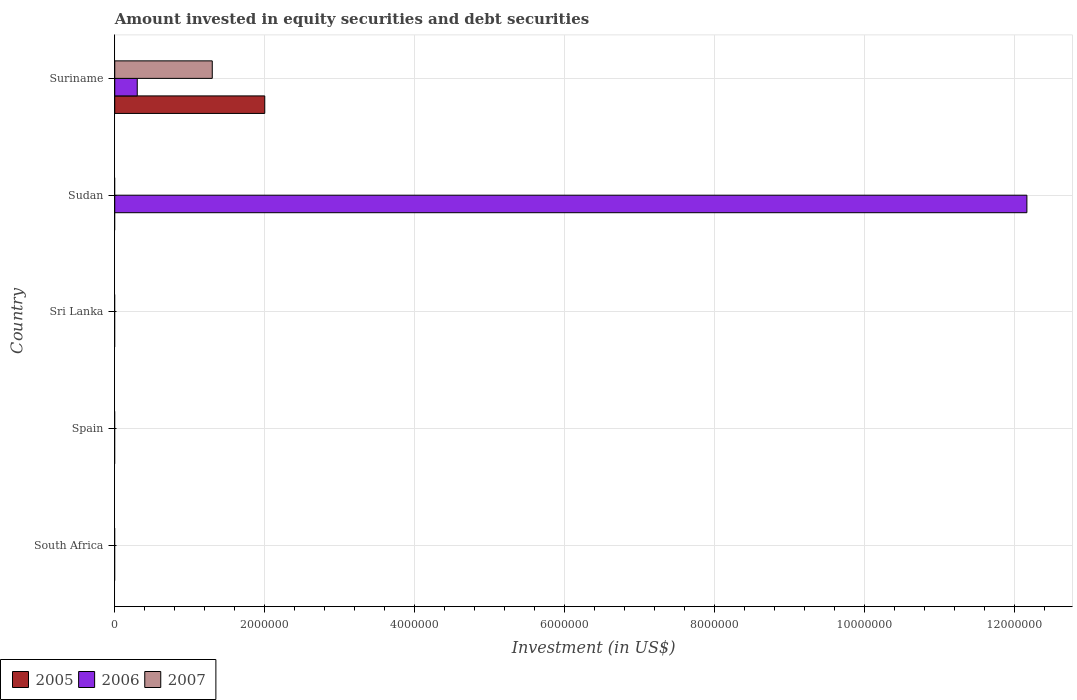How many different coloured bars are there?
Your answer should be very brief. 3. Are the number of bars per tick equal to the number of legend labels?
Give a very brief answer. No. Are the number of bars on each tick of the Y-axis equal?
Give a very brief answer. No. How many bars are there on the 5th tick from the bottom?
Offer a very short reply. 3. Across all countries, what is the maximum amount invested in equity securities and debt securities in 2007?
Keep it short and to the point. 1.30e+06. In which country was the amount invested in equity securities and debt securities in 2007 maximum?
Make the answer very short. Suriname. What is the total amount invested in equity securities and debt securities in 2007 in the graph?
Provide a succinct answer. 1.30e+06. In how many countries, is the amount invested in equity securities and debt securities in 2007 greater than 6800000 US$?
Keep it short and to the point. 0. What is the difference between the highest and the lowest amount invested in equity securities and debt securities in 2006?
Give a very brief answer. 1.22e+07. In how many countries, is the amount invested in equity securities and debt securities in 2007 greater than the average amount invested in equity securities and debt securities in 2007 taken over all countries?
Your answer should be compact. 1. Are all the bars in the graph horizontal?
Ensure brevity in your answer.  Yes. How many countries are there in the graph?
Ensure brevity in your answer.  5. What is the difference between two consecutive major ticks on the X-axis?
Offer a very short reply. 2.00e+06. Are the values on the major ticks of X-axis written in scientific E-notation?
Provide a succinct answer. No. Does the graph contain any zero values?
Your answer should be compact. Yes. Does the graph contain grids?
Provide a succinct answer. Yes. How many legend labels are there?
Keep it short and to the point. 3. What is the title of the graph?
Offer a terse response. Amount invested in equity securities and debt securities. What is the label or title of the X-axis?
Ensure brevity in your answer.  Investment (in US$). What is the Investment (in US$) of 2007 in Spain?
Your response must be concise. 0. What is the Investment (in US$) of 2005 in Sri Lanka?
Ensure brevity in your answer.  0. What is the Investment (in US$) in 2006 in Sri Lanka?
Your answer should be compact. 0. What is the Investment (in US$) of 2006 in Sudan?
Make the answer very short. 1.22e+07. What is the Investment (in US$) in 2007 in Sudan?
Provide a short and direct response. 0. What is the Investment (in US$) of 2007 in Suriname?
Your answer should be very brief. 1.30e+06. Across all countries, what is the maximum Investment (in US$) of 2005?
Your response must be concise. 2.00e+06. Across all countries, what is the maximum Investment (in US$) of 2006?
Offer a very short reply. 1.22e+07. Across all countries, what is the maximum Investment (in US$) in 2007?
Ensure brevity in your answer.  1.30e+06. Across all countries, what is the minimum Investment (in US$) of 2005?
Give a very brief answer. 0. Across all countries, what is the minimum Investment (in US$) in 2007?
Offer a very short reply. 0. What is the total Investment (in US$) of 2005 in the graph?
Keep it short and to the point. 2.00e+06. What is the total Investment (in US$) in 2006 in the graph?
Provide a short and direct response. 1.25e+07. What is the total Investment (in US$) of 2007 in the graph?
Offer a very short reply. 1.30e+06. What is the difference between the Investment (in US$) of 2006 in Sudan and that in Suriname?
Your answer should be very brief. 1.19e+07. What is the difference between the Investment (in US$) in 2006 in Sudan and the Investment (in US$) in 2007 in Suriname?
Offer a terse response. 1.09e+07. What is the average Investment (in US$) of 2005 per country?
Provide a short and direct response. 4.00e+05. What is the average Investment (in US$) in 2006 per country?
Your answer should be very brief. 2.49e+06. What is the average Investment (in US$) of 2007 per country?
Offer a terse response. 2.60e+05. What is the difference between the Investment (in US$) of 2005 and Investment (in US$) of 2006 in Suriname?
Your answer should be very brief. 1.70e+06. What is the difference between the Investment (in US$) in 2006 and Investment (in US$) in 2007 in Suriname?
Provide a succinct answer. -1.00e+06. What is the ratio of the Investment (in US$) in 2006 in Sudan to that in Suriname?
Ensure brevity in your answer.  40.54. What is the difference between the highest and the lowest Investment (in US$) in 2006?
Your response must be concise. 1.22e+07. What is the difference between the highest and the lowest Investment (in US$) of 2007?
Give a very brief answer. 1.30e+06. 